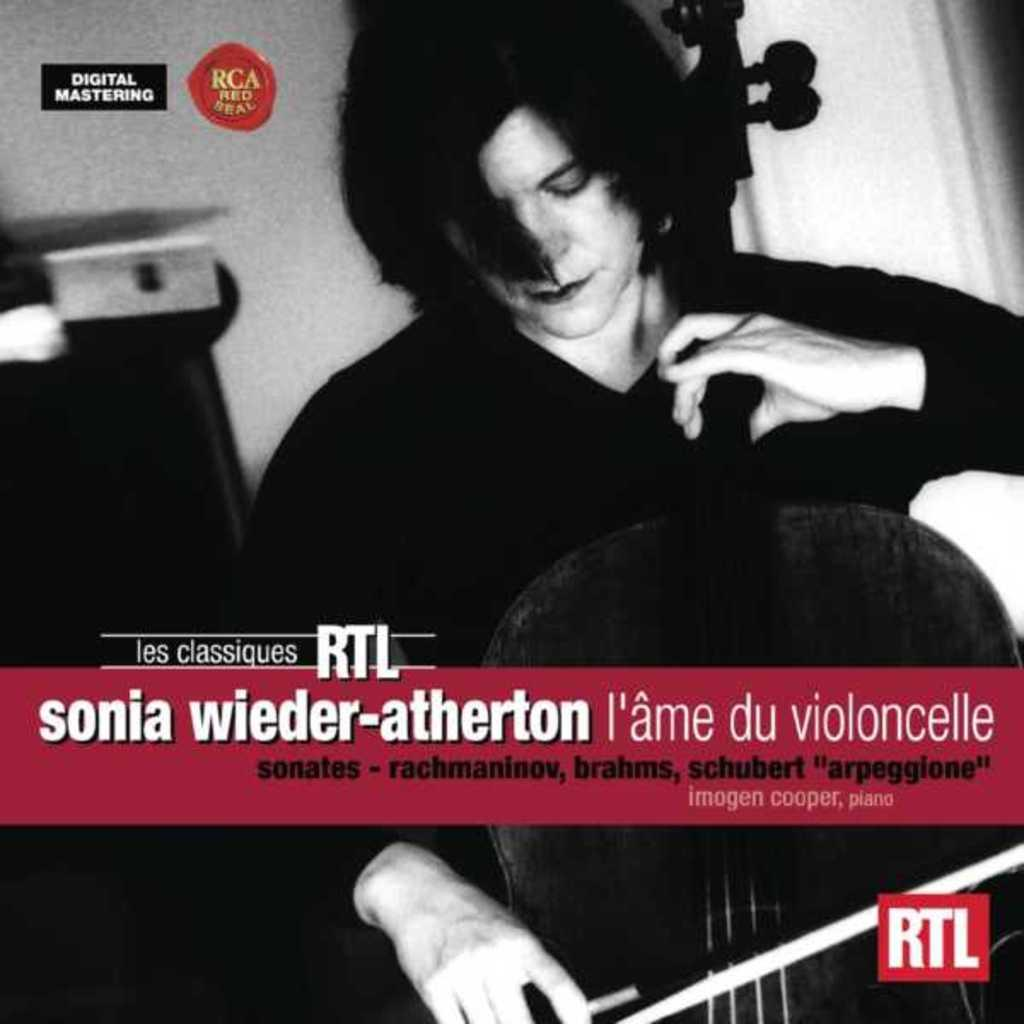What is the color scheme of the image? The image is black and white. What is the main subject of the image? There is a person in the image. What is the person doing in the image? The person is playing a violin. Is there any text present in the image? Yes, there is text written on the image. Can you tell me how many grapes are on the table in the image? There are no grapes present in the image; it features a person playing a violin in a black and white setting with text. Is there a book visible in the image? There is no book visible in the image. 